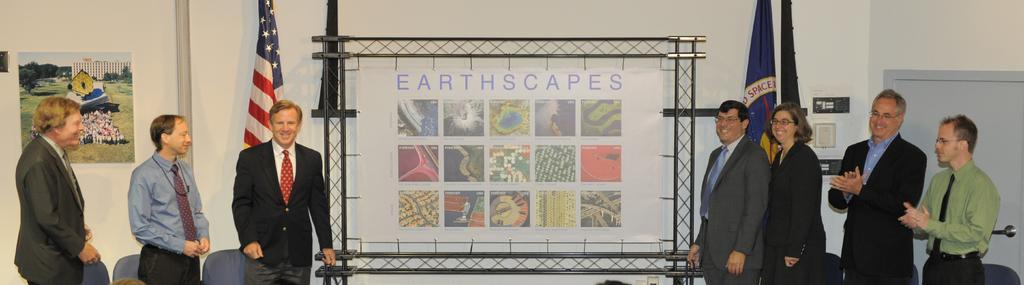Could you give a brief overview of what you see in this image? There is a white color banner which has earthscapes and few pictures on it and there are few persons standing on either sides of it. 